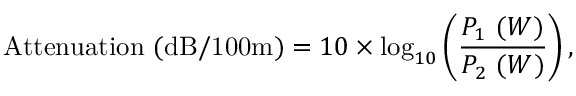<formula> <loc_0><loc_0><loc_500><loc_500>{ A t t e n u a t i o n ( d B / 1 0 0 m ) } = 1 0 \times \log _ { 1 0 } \left ( { \frac { P _ { 1 } \ ( W ) } { P _ { 2 } \ ( W ) } } \right ) ,</formula> 